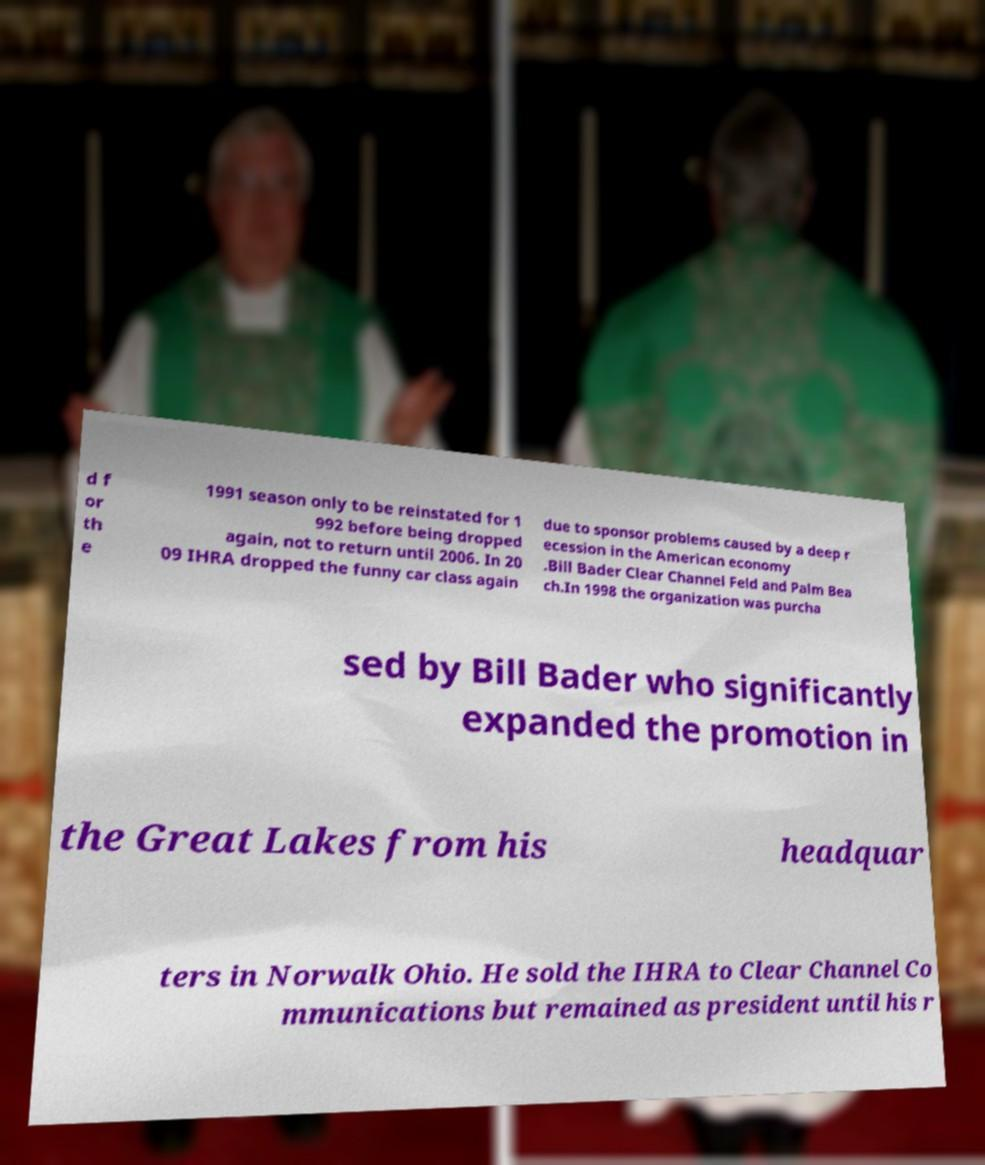Can you read and provide the text displayed in the image?This photo seems to have some interesting text. Can you extract and type it out for me? d f or th e 1991 season only to be reinstated for 1 992 before being dropped again, not to return until 2006. In 20 09 IHRA dropped the funny car class again due to sponsor problems caused by a deep r ecession in the American economy .Bill Bader Clear Channel Feld and Palm Bea ch.In 1998 the organization was purcha sed by Bill Bader who significantly expanded the promotion in the Great Lakes from his headquar ters in Norwalk Ohio. He sold the IHRA to Clear Channel Co mmunications but remained as president until his r 